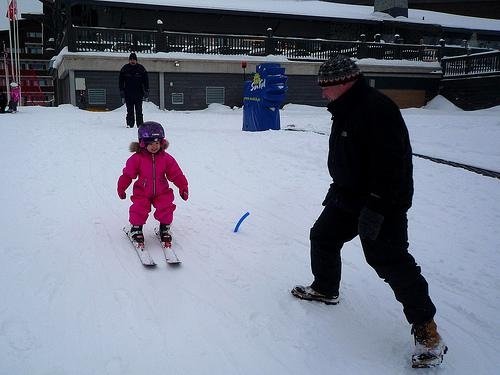Question: what activity is being performed here?
Choices:
A. Skiing.
B. Softball game.
C. Skateboarding.
D. Eating.
Answer with the letter. Answer: A Question: what color is the girl's snowsuit?
Choices:
A. Blue.
B. Green.
C. Pink.
D. Red.
Answer with the letter. Answer: C Question: what color helmet is the girl wearing?
Choices:
A. Purple.
B. Red.
C. Black.
D. Blue.
Answer with the letter. Answer: A Question: when was this picture taken?
Choices:
A. January.
B. Last night.
C. Winter.
D. Morning.
Answer with the letter. Answer: C Question: where is this picture likely taken?
Choices:
A. A ski resort.
B. In a forest.
C. In a car.
D. At the zoo.
Answer with the letter. Answer: A 